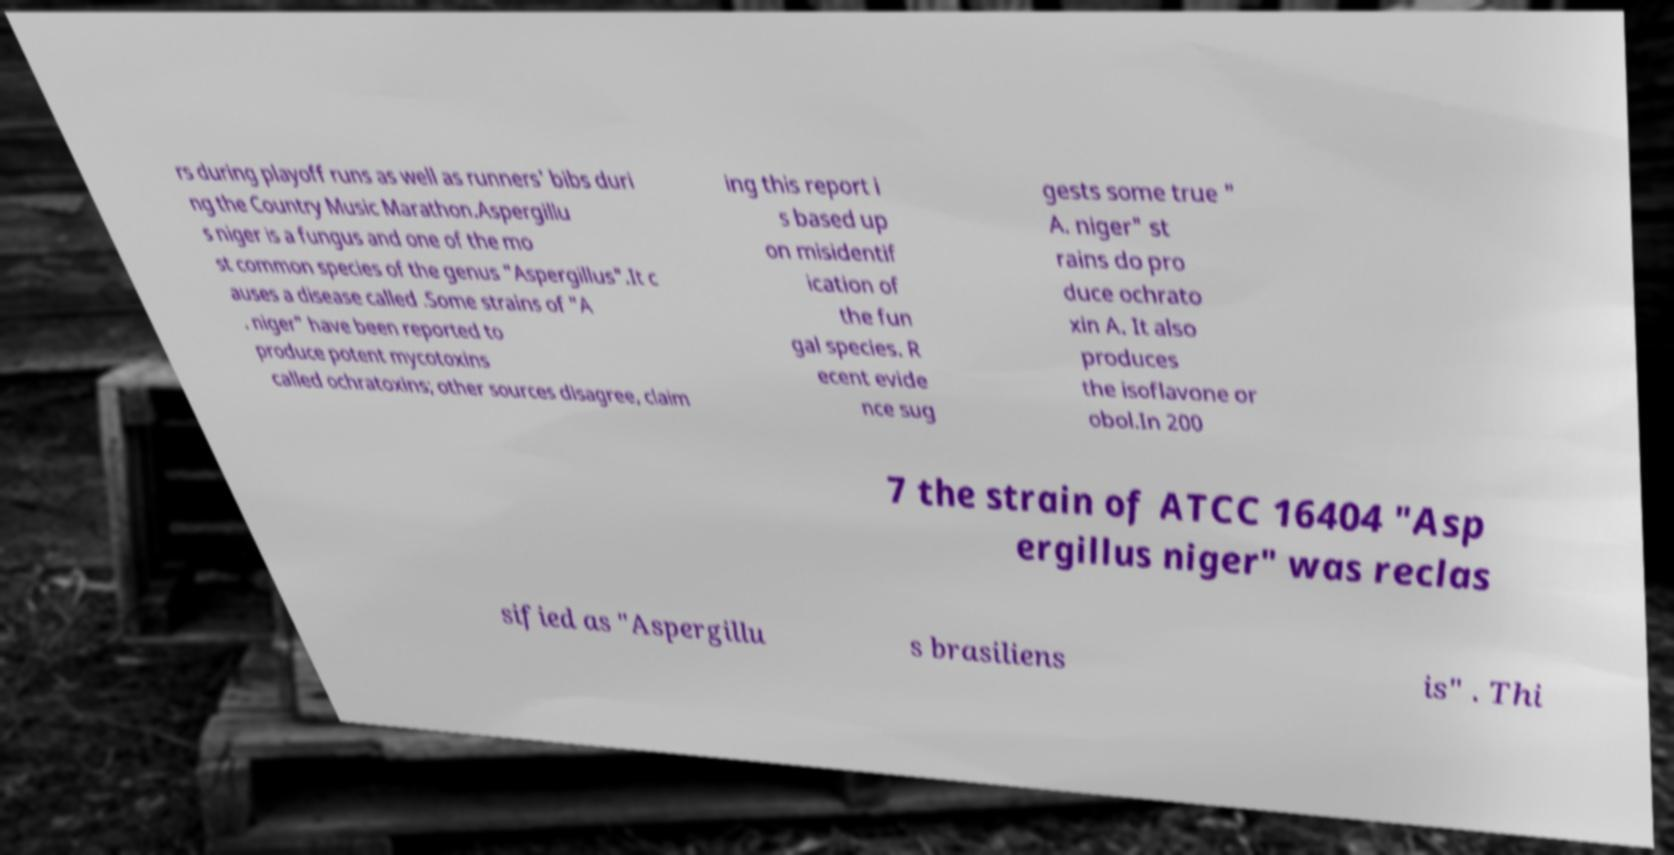Can you accurately transcribe the text from the provided image for me? rs during playoff runs as well as runners' bibs duri ng the Country Music Marathon.Aspergillu s niger is a fungus and one of the mo st common species of the genus "Aspergillus".It c auses a disease called .Some strains of "A . niger" have been reported to produce potent mycotoxins called ochratoxins; other sources disagree, claim ing this report i s based up on misidentif ication of the fun gal species. R ecent evide nce sug gests some true " A. niger" st rains do pro duce ochrato xin A. It also produces the isoflavone or obol.In 200 7 the strain of ATCC 16404 "Asp ergillus niger" was reclas sified as "Aspergillu s brasiliens is" . Thi 